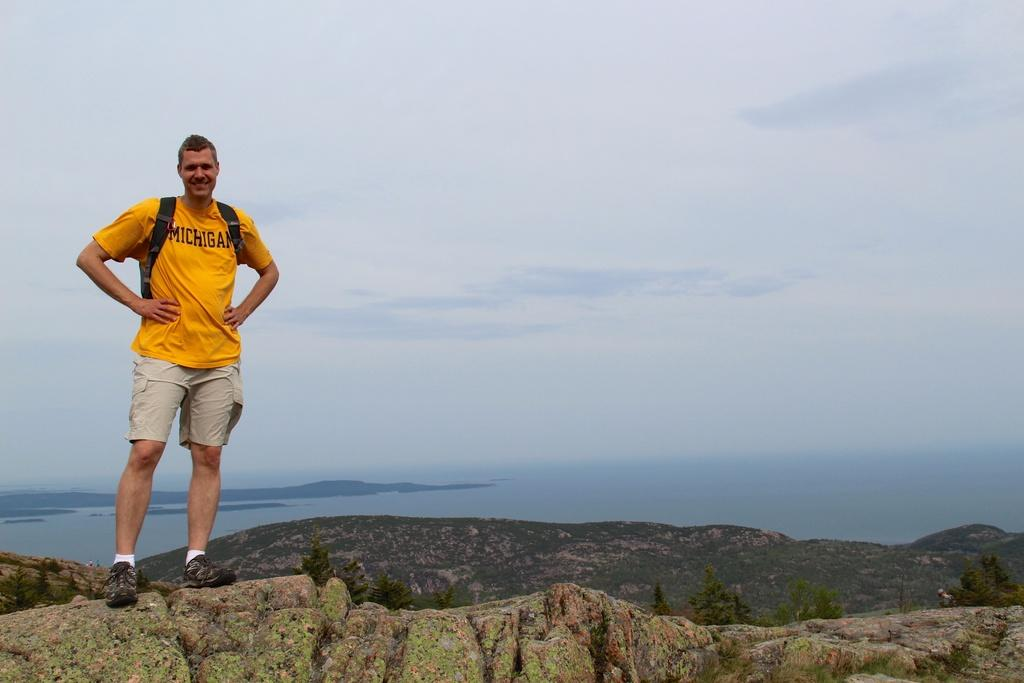Who is present in the image? There is a person in the image. What is the person doing in the image? The person is standing with a smile on his face. What can be seen in the distance behind the person? There are mountains, a river, and the sky visible in the background of the image. What direction is the person facing in the image? The provided facts do not specify the direction the person is facing in the image. 